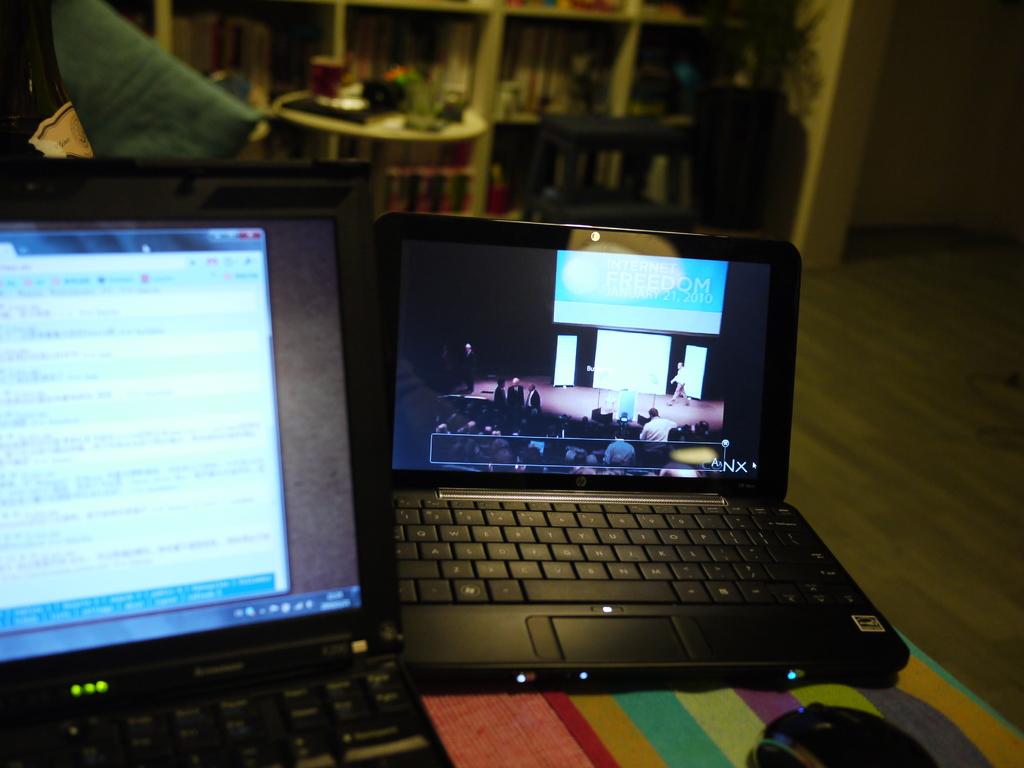What brand of computer?
Offer a very short reply. Hp. 